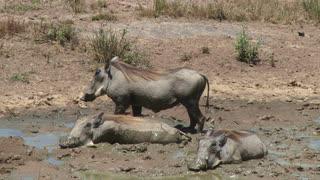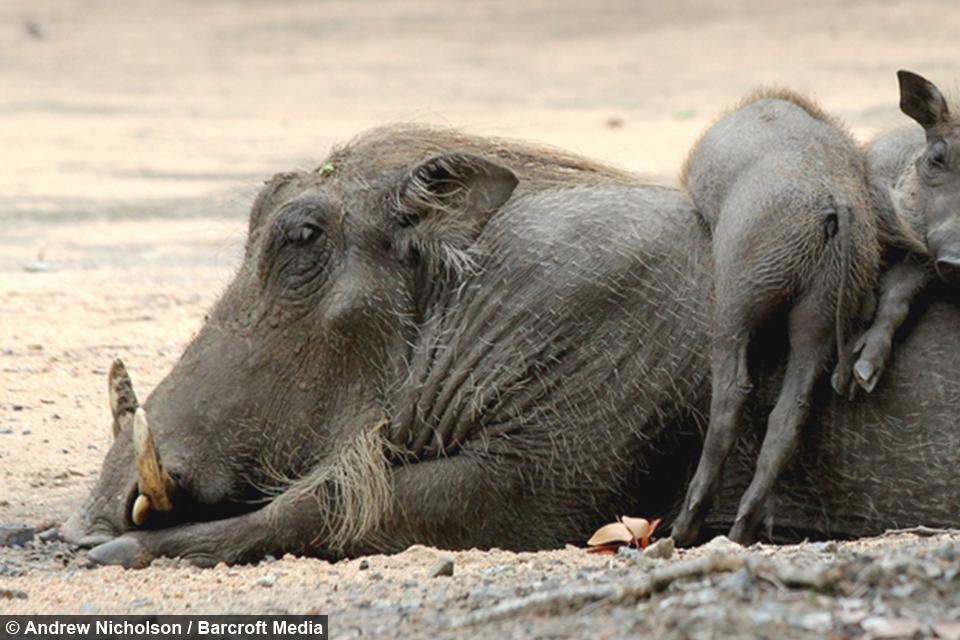The first image is the image on the left, the second image is the image on the right. Analyze the images presented: Is the assertion "At least one warthog is wading in mud in one of the images." valid? Answer yes or no. Yes. The first image is the image on the left, the second image is the image on the right. For the images shown, is this caption "The right image contains no more than two wart hogs." true? Answer yes or no. No. 